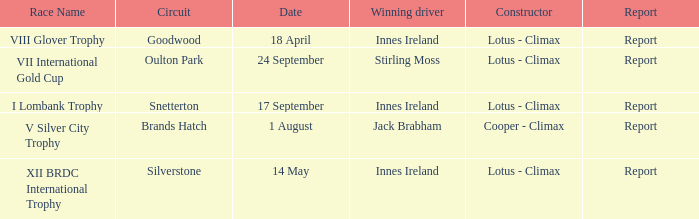What is the name of the race where Stirling Moss was the winning driver? VII International Gold Cup. 